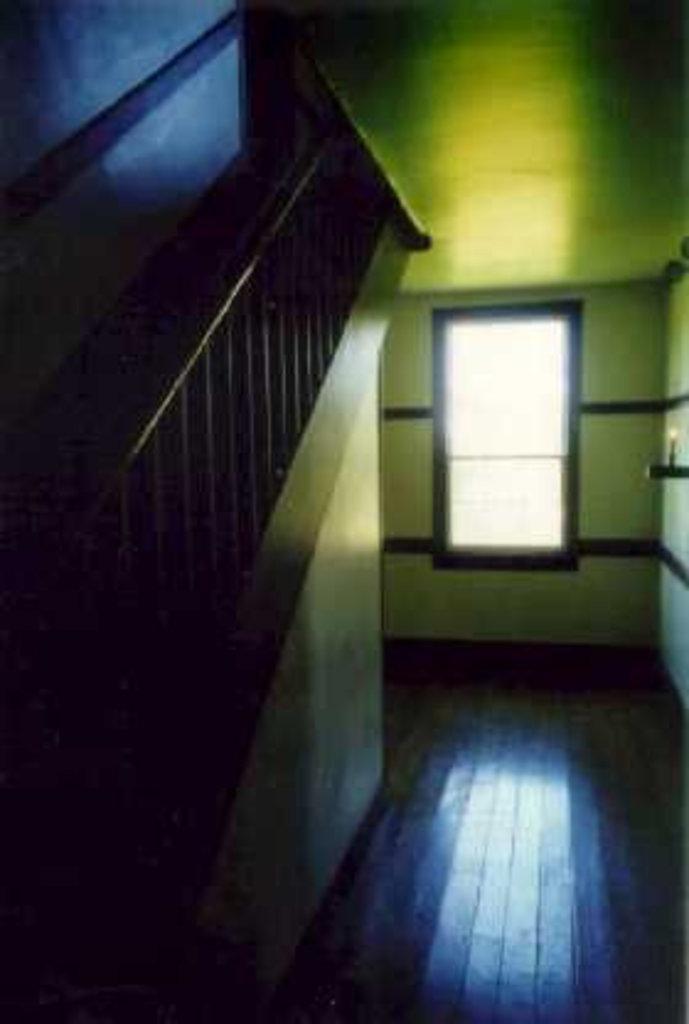Please provide a concise description of this image. In this image on the left side there is a wall and there is a staircase. In the background there is a window. 